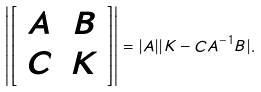Convert formula to latex. <formula><loc_0><loc_0><loc_500><loc_500>\left | \left [ \begin{array} { c c } A & B \\ C & K \end{array} \right ] \right | = | A | | K - C A ^ { - 1 } B | .</formula> 